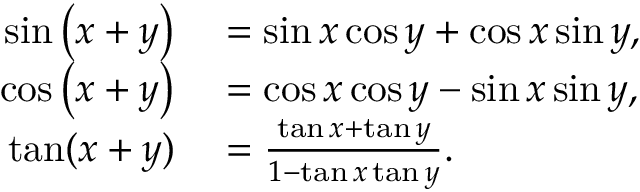Convert formula to latex. <formula><loc_0><loc_0><loc_500><loc_500>\begin{array} { r l } { \sin \left ( x + y \right ) } & = \sin x \cos y + \cos x \sin y , } \\ { \cos \left ( x + y \right ) } & = \cos x \cos y - \sin x \sin y , } \\ { \tan ( x + y ) } & = { \frac { \tan x + \tan y } { 1 - \tan x \tan y } } . } \end{array}</formula> 